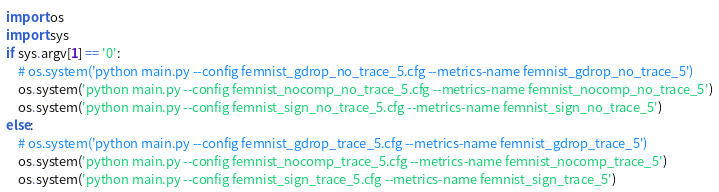<code> <loc_0><loc_0><loc_500><loc_500><_Python_>import os
import sys
if sys.argv[1] == '0':
    # os.system('python main.py --config femnist_gdrop_no_trace_5.cfg --metrics-name femnist_gdrop_no_trace_5')
    os.system('python main.py --config femnist_nocomp_no_trace_5.cfg --metrics-name femnist_nocomp_no_trace_5')
    os.system('python main.py --config femnist_sign_no_trace_5.cfg --metrics-name femnist_sign_no_trace_5')
else:
    # os.system('python main.py --config femnist_gdrop_trace_5.cfg --metrics-name femnist_gdrop_trace_5')
    os.system('python main.py --config femnist_nocomp_trace_5.cfg --metrics-name femnist_nocomp_trace_5')
    os.system('python main.py --config femnist_sign_trace_5.cfg --metrics-name femnist_sign_trace_5')</code> 